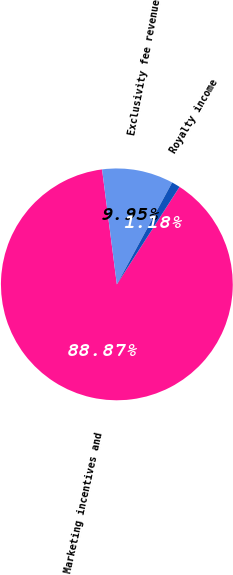Convert chart to OTSL. <chart><loc_0><loc_0><loc_500><loc_500><pie_chart><fcel>Marketing incentives and<fcel>Exclusivity fee revenue<fcel>Royalty income<nl><fcel>88.87%<fcel>9.95%<fcel>1.18%<nl></chart> 